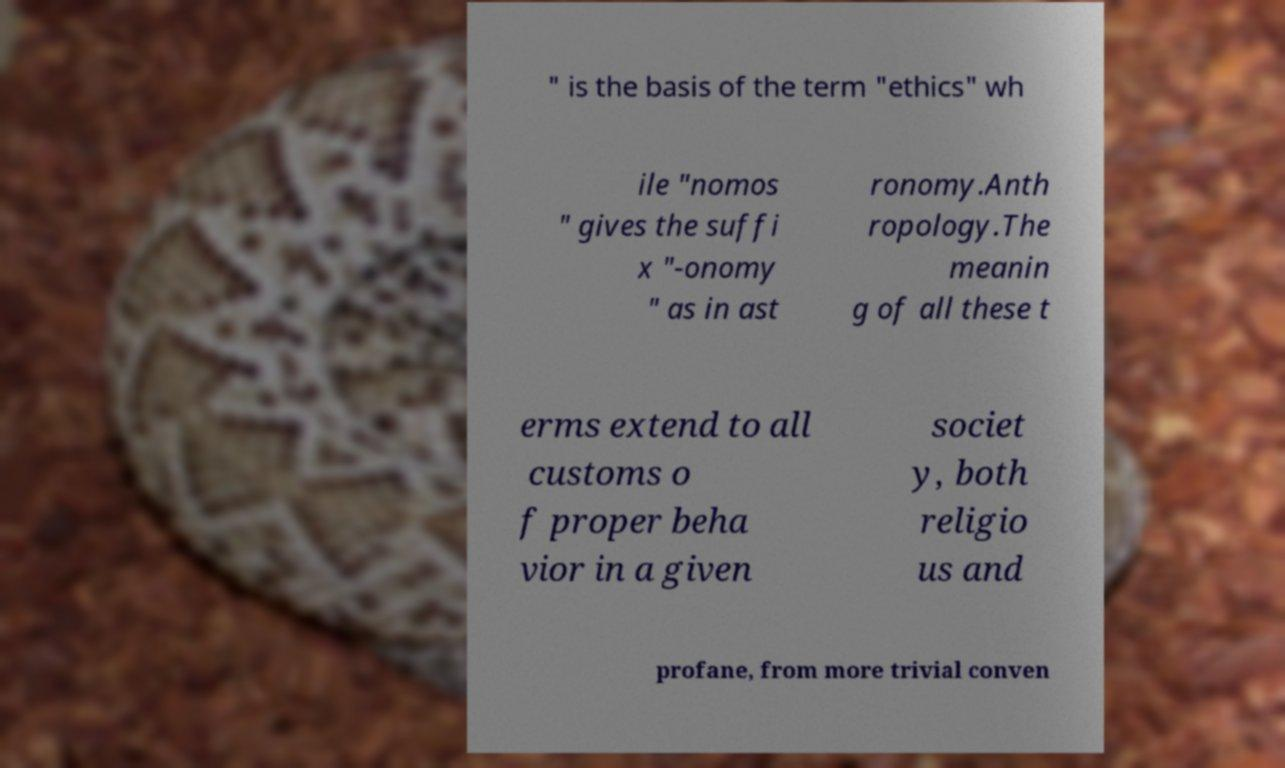Could you extract and type out the text from this image? " is the basis of the term "ethics" wh ile "nomos " gives the suffi x "-onomy " as in ast ronomy.Anth ropology.The meanin g of all these t erms extend to all customs o f proper beha vior in a given societ y, both religio us and profane, from more trivial conven 